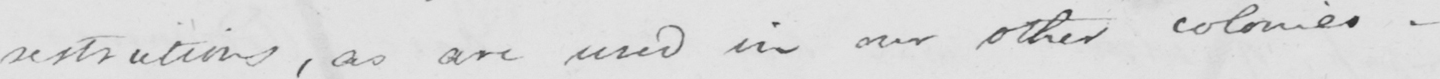Can you read and transcribe this handwriting? restrictions , as are used in our other colonies . 